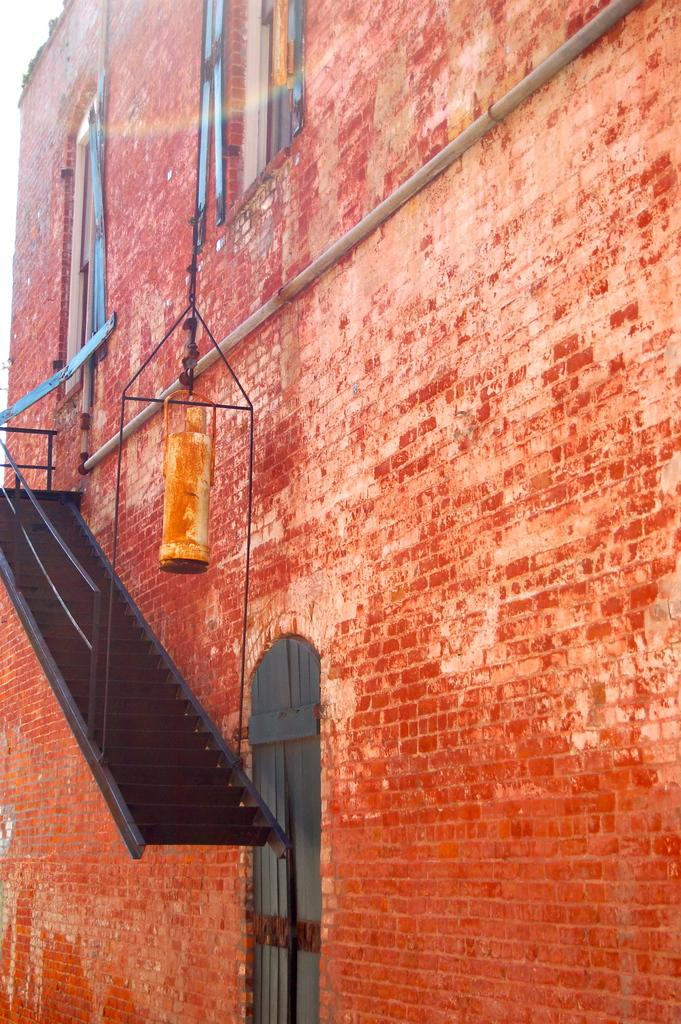What type of structure is visible in the image? There is a building in the image. What features can be seen on the building? The building has windows, stairs, and a door. What type of yoke is attached to the building in the image? There is no yoke present in the image; it is a building with windows, stairs, and a door. 